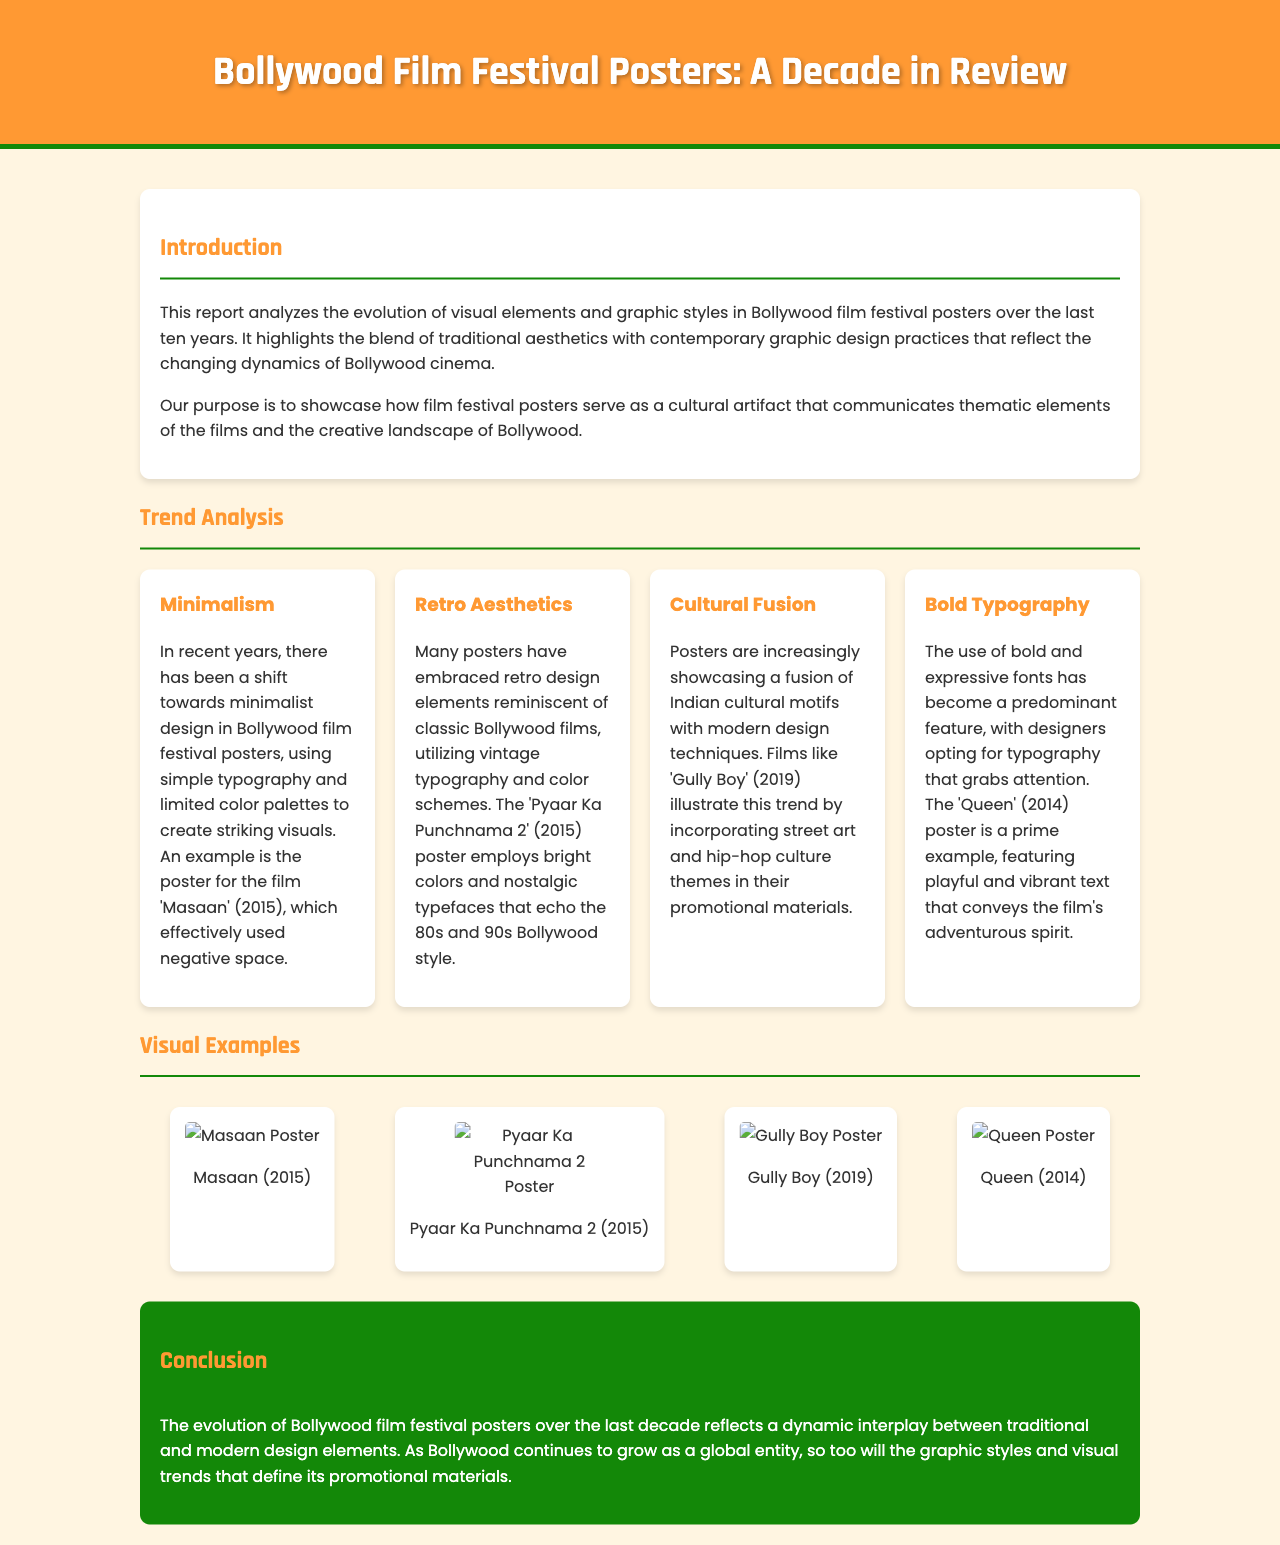What is the title of the report? The title of the report is found at the top of the document, which is "Bollywood Film Festival Posters: A Decade in Review."
Answer: Bollywood Film Festival Posters: A Decade in Review What are the four trends identified in the analysis? The trends identified include Minimalism, Retro Aesthetics, Cultural Fusion, and Bold Typography.
Answer: Minimalism, Retro Aesthetics, Cultural Fusion, Bold Typography Which film’s poster exemplifies the use of bold typography? The document mentions that the 'Queen' (2014) poster is a prime example of bold typography usage.
Answer: Queen (2014) What year was the film 'Gully Boy' released? The release year of 'Gully Boy' is stated in the document, which is 2019.
Answer: 2019 How does the report describe the overall evolution of Bollywood film posters? The conclusion summarizes this evolution as a dynamic interplay between traditional and modern design elements.
Answer: Dynamic interplay between traditional and modern design elements Which color is specified in the background of the header? The document specifies the header background color as #FF9933.
Answer: #FF9933 What type of design has seen a shift in the film festival posters recently? The trend of minimalism has seen a shift in Bollywood film festival posters recently.
Answer: Minimalism What is the purpose of analyzing film festival posters according to the introduction? The introduction states that the purpose is to showcase how film festival posters communicate thematic elements of the films and the creative landscape of Bollywood.
Answer: Communicate thematic elements of the films and the creative landscape of Bollywood 